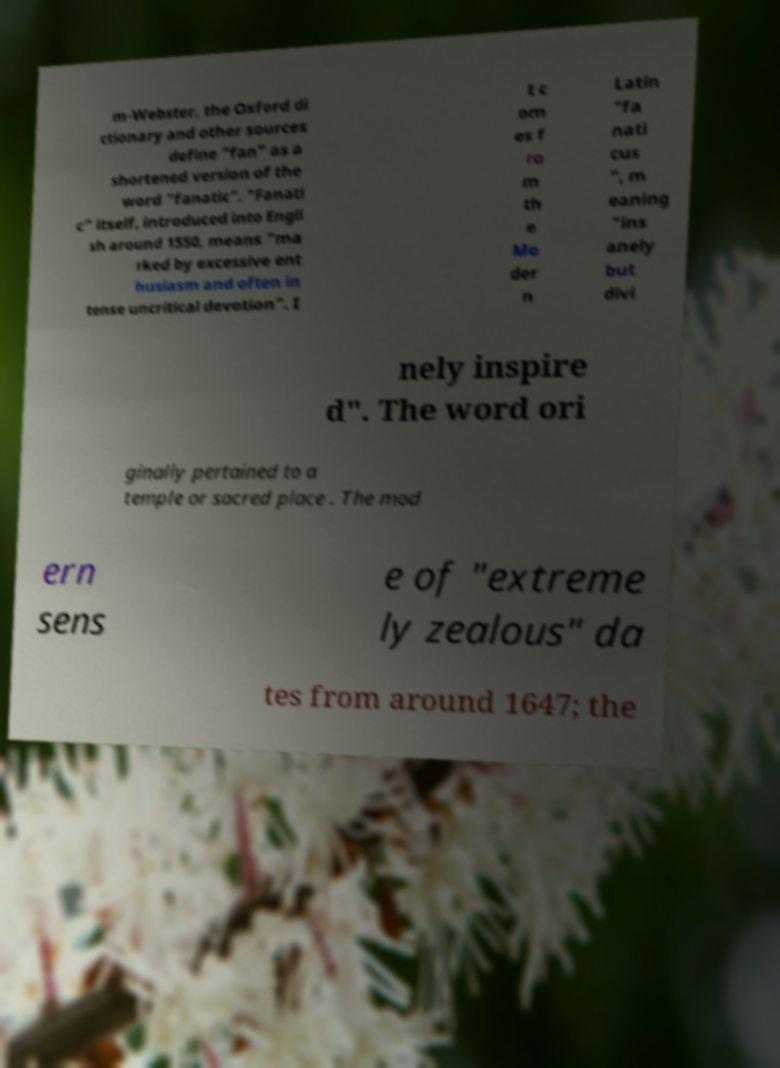There's text embedded in this image that I need extracted. Can you transcribe it verbatim? m-Webster, the Oxford di ctionary and other sources define "fan" as a shortened version of the word "fanatic". "Fanati c" itself, introduced into Engli sh around 1550, means "ma rked by excessive ent husiasm and often in tense uncritical devotion". I t c om es f ro m th e Mo der n Latin "fa nati cus ", m eaning "ins anely but divi nely inspire d". The word ori ginally pertained to a temple or sacred place . The mod ern sens e of "extreme ly zealous" da tes from around 1647; the 